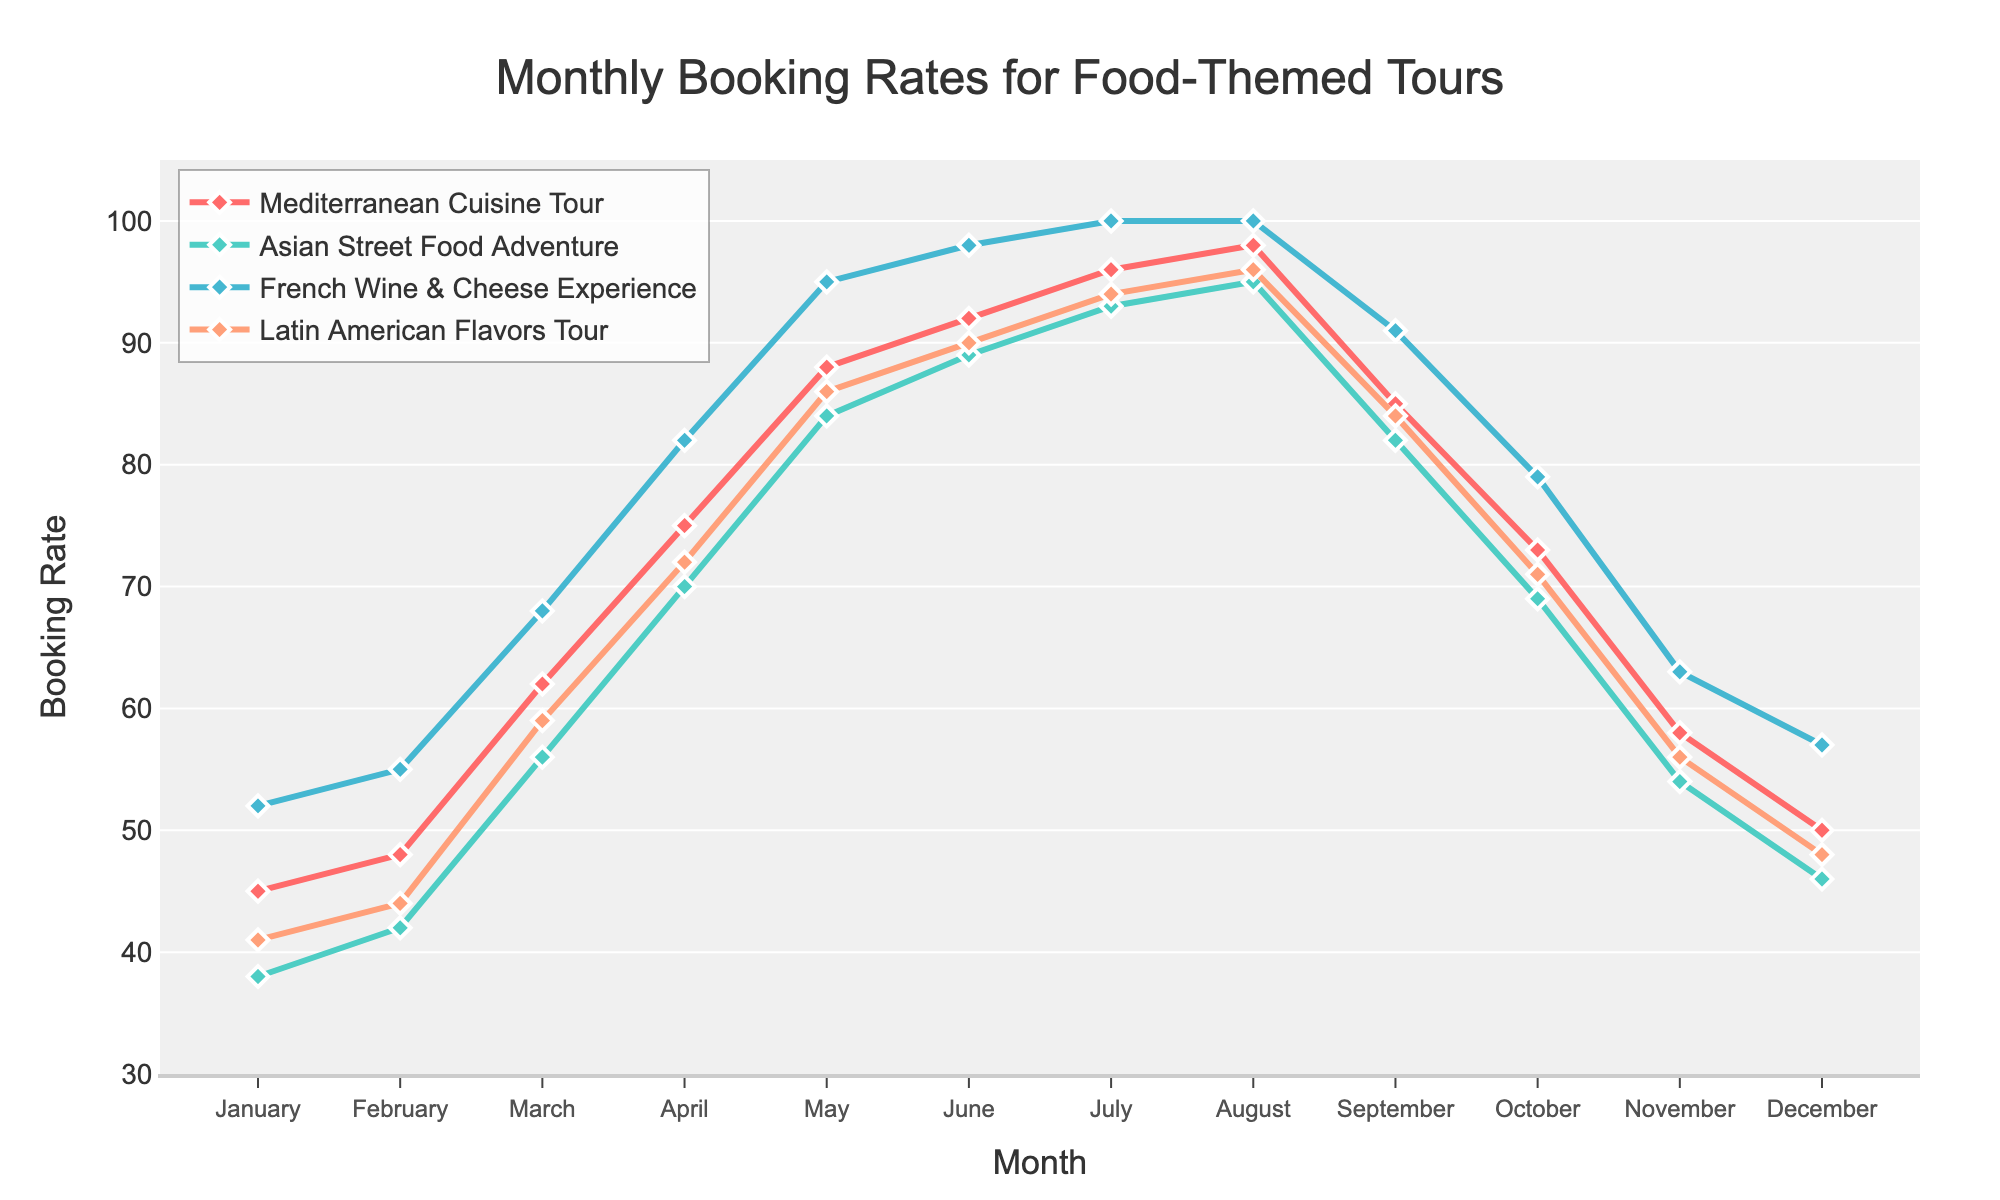What's the month with the highest booking rates for all tours? By observing the plot, the peak point for all tours appears in August. This month exhibits the highest booking rates for 'Mediterranean Cuisine Tour', 'Asian Street Food Adventure', and almost all other tours.
Answer: August Which tour has the highest average booking rate over the year? To find the highest average booking rate, calculate the average bookings for each tour. The tour with the maximum average value over the year is identified as having the highest average booking rate. Mediterranean Cuisine Tour: (45+48+62+75+88+92+96+98+85+73+58+50)/12 = 72.4. Asian Street Food Adventure: (38+42+56+70+84+89+93+95+82+69+54+46)/12 = 69.75. French Wine & Cheese Experience: (52+55+68+82+95+98+100+100+91+79+63+57)/12 = 77. Latin American Flavors Tour: (41+44+59+72+86+90+94+96+84+71+56+48)/12 = 69.75. Thus, the French Wine & Cheese Experience tour has the highest average booking rate over the year.
Answer: French Wine & Cheese Experience Which tour has the lowest booking rate in December? Observe the plot to identify the lowest booking rate in December by comparing the values for all tours. The 'Asian Street Food Adventure' shows the lowest point in December among the four tours.
Answer: Asian Street Food Adventure What is the difference in the booking rates between 'Mediterranean Cuisine Tour' and 'Latin American Flavors Tour' in July? Check the booking rates in July for both tours from the plot. 'Mediterranean Cuisine Tour' has a booking rate of 96, while 'Latin American Flavors Tour' has a booking rate of 94. Therefore, the difference is 96 - 94.
Answer: 2 In which month do we observe the largest increase in booking rates for 'Asian Street Food Adventure' from the previous month? By looking at the plot, calculate the change in booking rates for 'Asian Street Food Adventure' from month to month. The largest increase is observed from January (38) to February (42), a difference of 4. From February to March, the increase is 14 (42 to 56). From March to April, it is 14 (56 to 70). Comparing these, from March to April, the largest increase is observed.
Answer: March to April How do the booking rates of 'French Wine & Cheese Experience' and 'Asian Street Food Adventure' compare in June? Check the booking rates in June for 'French Wine & Cheese Experience' and 'Asian Street Food Adventure' from the plot. 'French Wine & Cheese Experience' has a rate of 98, while 'Asian Street Food Adventure' has a rate of 89. 'French Wine & Cheese Experience' has a higher booking rate than 'Asian Street Food Adventure' in June.
Answer: French Wine & Cheese Experience is higher What is the total booking rate accumulated by the 'Latin American Flavors Tour' over the summer months (June, July, August)? Sum the booking rates for 'Latin American Flavors Tour' for June (90), July (94), and August (96). 90 + 94 + 96 = 280.
Answer: 280 Which month displays the steepest decline in bookings for all tours combined? To determine the steepest decline, compare consecutive monthly booking rates for each tour and sum them up. The month with the steepest decline will be the one where this sum is the largest negative value. From August (98, 95, 100, 96) to September (85, 82, 91, 84), the total decline is a significant portion, reflecting the sharpest combined decline.
Answer: August to September What is the average booking rate for the 'Mediterranean Cuisine Tour' during the winter months (December, January, February)? Calculate the average of the booking rates for December (50), January (45), and February (48). Average = (50 + 45 + 48) / 3 = 47.67.
Answer: 47.67 